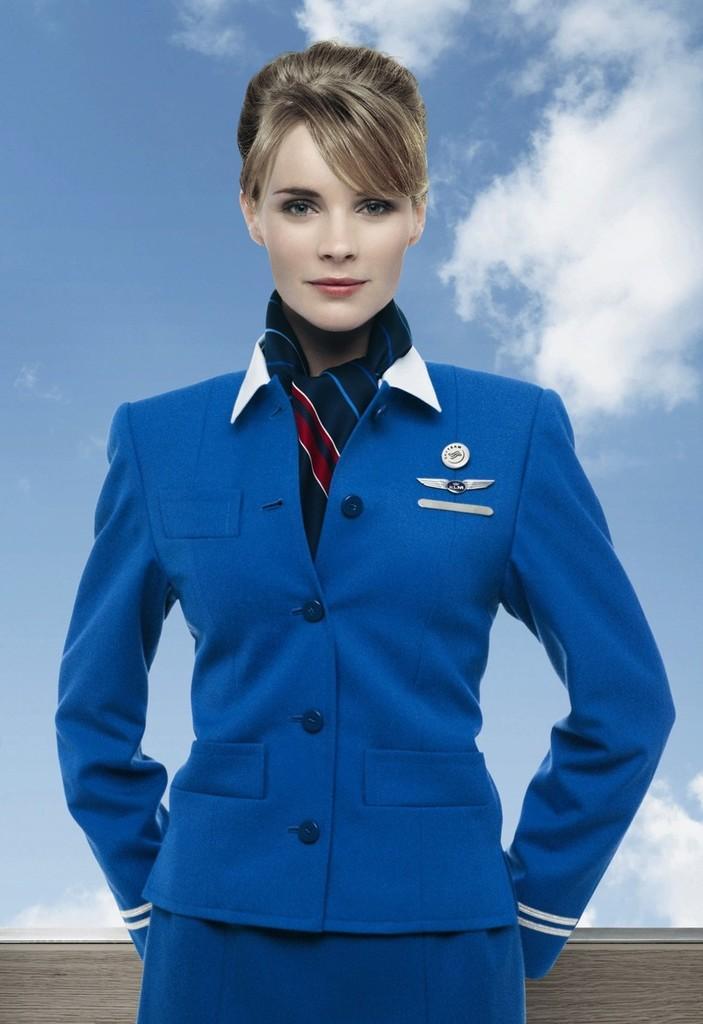Describe this image in one or two sentences. In the image we can see the woman in the middle of the image. The woman is wearing clothes and she is smiling, and here we can see the cloudy sky. 